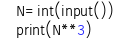<code> <loc_0><loc_0><loc_500><loc_500><_Python_>N=int(input())
print(N**3)</code> 